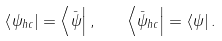<formula> <loc_0><loc_0><loc_500><loc_500>\left \langle \psi _ { h c } \right | = \left \langle \bar { \psi } \right | , \quad \left \langle \bar { \psi } _ { h c } \right | = \left \langle \psi \right | .</formula> 